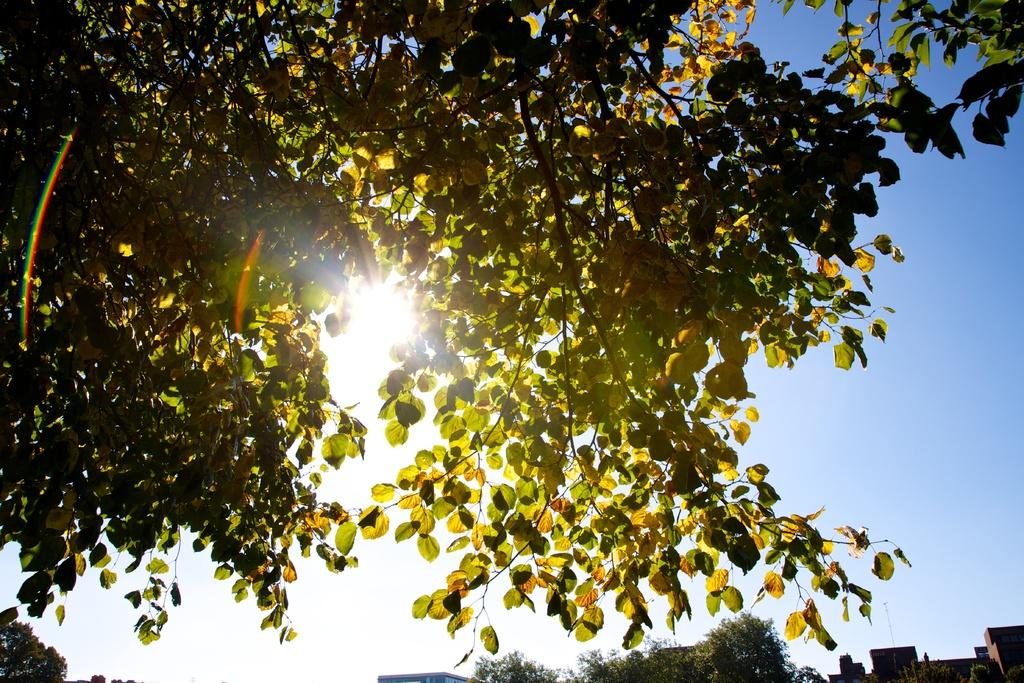What is the main object in the image? There is a tree in the image. What can be seen behind the tree? The sky is visible behind the tree. What is present in the sky? The sun is present in the sky. What is located at the bottom of the image? Trees and buildings are present at the bottom of the image. What type of copper can be seen in the throat of the tree in the image? There is no copper or throat present in the image; it features a tree with a sky background. 